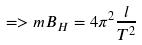Convert formula to latex. <formula><loc_0><loc_0><loc_500><loc_500>= > m B _ { H } = 4 \pi ^ { 2 } \frac { l } { T ^ { 2 } }</formula> 